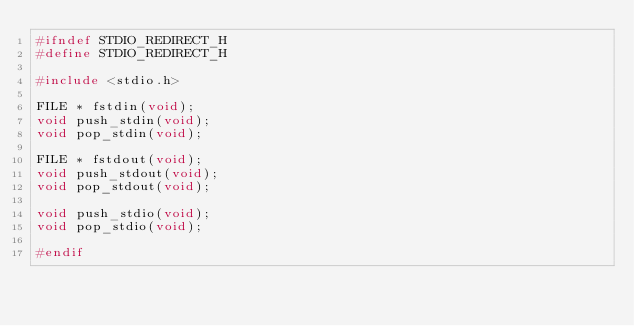Convert code to text. <code><loc_0><loc_0><loc_500><loc_500><_C_>#ifndef STDIO_REDIRECT_H
#define STDIO_REDIRECT_H

#include <stdio.h>

FILE * fstdin(void);
void push_stdin(void);
void pop_stdin(void);

FILE * fstdout(void);
void push_stdout(void);
void pop_stdout(void);

void push_stdio(void);
void pop_stdio(void);

#endif</code> 